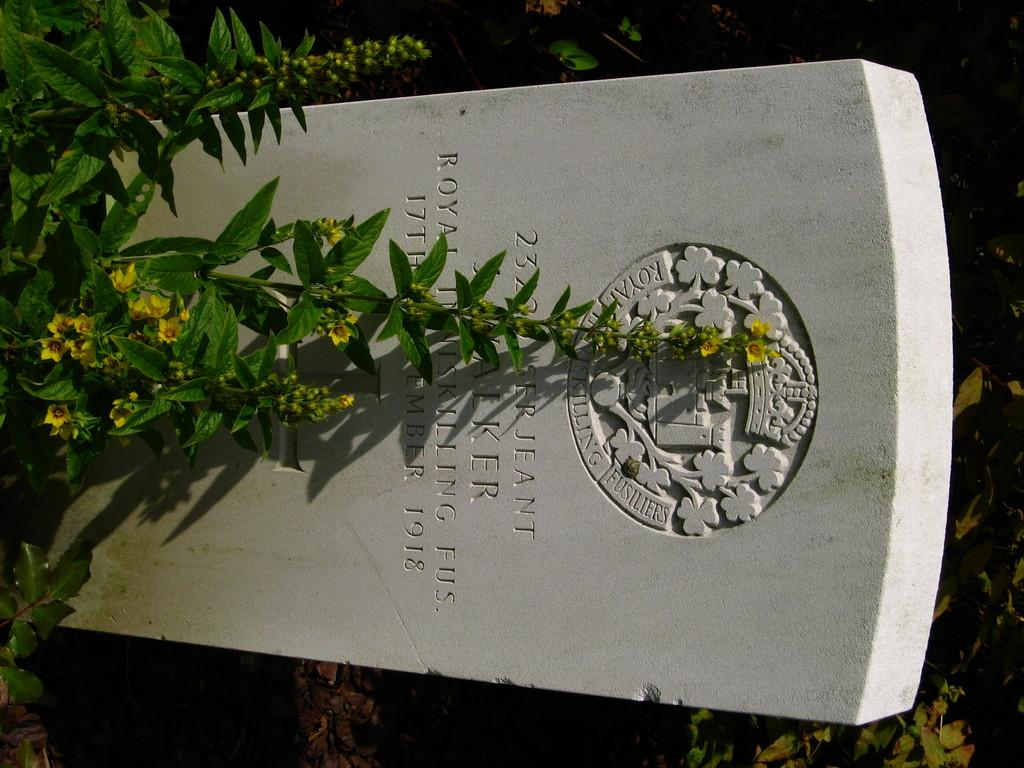What type of location is depicted in the image? There is a cemetery in the image. What color are the flowers in the image? The flowers in the image are yellow. What color are the plants in the image? The plants in the image are green. What shape is the haircut of the person in the image? There is no person present in the image, so there is no haircut to describe. 